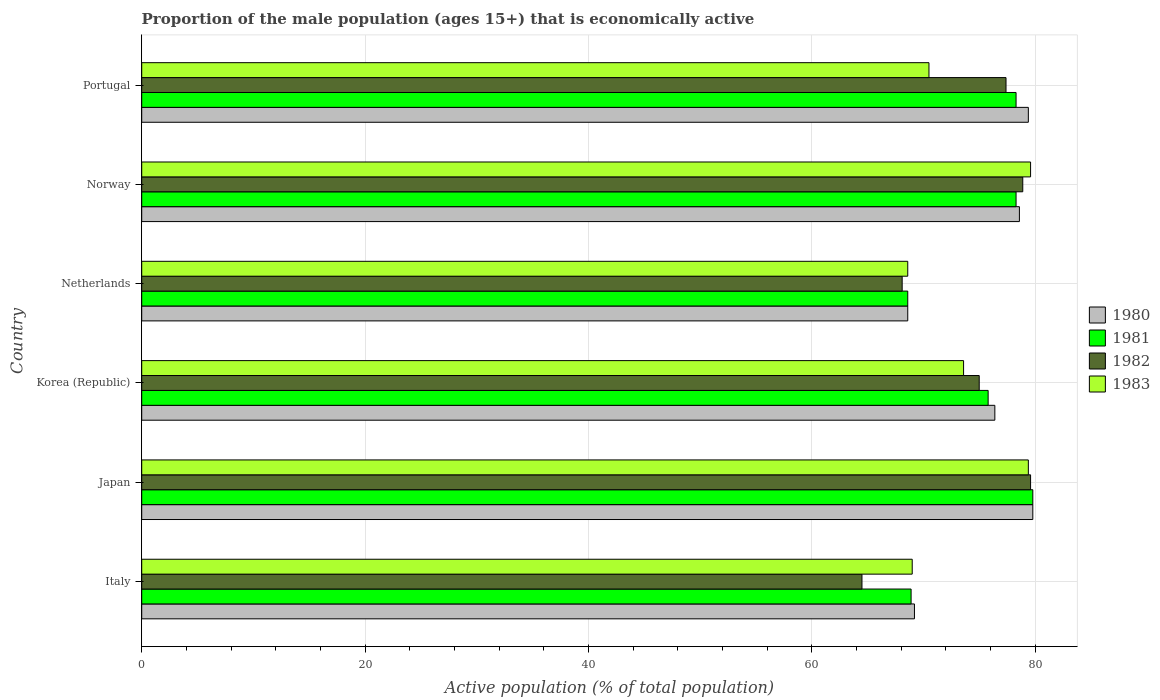How many different coloured bars are there?
Keep it short and to the point. 4. Are the number of bars per tick equal to the number of legend labels?
Make the answer very short. Yes. Are the number of bars on each tick of the Y-axis equal?
Provide a succinct answer. Yes. How many bars are there on the 6th tick from the bottom?
Give a very brief answer. 4. What is the proportion of the male population that is economically active in 1983 in Portugal?
Provide a short and direct response. 70.5. Across all countries, what is the maximum proportion of the male population that is economically active in 1983?
Your answer should be very brief. 79.6. Across all countries, what is the minimum proportion of the male population that is economically active in 1983?
Your answer should be compact. 68.6. In which country was the proportion of the male population that is economically active in 1982 maximum?
Keep it short and to the point. Japan. What is the total proportion of the male population that is economically active in 1982 in the graph?
Provide a short and direct response. 443.5. What is the difference between the proportion of the male population that is economically active in 1981 in Portugal and the proportion of the male population that is economically active in 1983 in Norway?
Make the answer very short. -1.3. What is the average proportion of the male population that is economically active in 1980 per country?
Your response must be concise. 75.33. What is the difference between the proportion of the male population that is economically active in 1981 and proportion of the male population that is economically active in 1982 in Norway?
Ensure brevity in your answer.  -0.6. What is the ratio of the proportion of the male population that is economically active in 1981 in Japan to that in Portugal?
Your answer should be very brief. 1.02. What is the difference between the highest and the second highest proportion of the male population that is economically active in 1983?
Your answer should be compact. 0.2. What is the difference between the highest and the lowest proportion of the male population that is economically active in 1982?
Offer a very short reply. 15.1. Is the sum of the proportion of the male population that is economically active in 1981 in Korea (Republic) and Portugal greater than the maximum proportion of the male population that is economically active in 1980 across all countries?
Keep it short and to the point. Yes. What does the 2nd bar from the bottom in Korea (Republic) represents?
Keep it short and to the point. 1981. Is it the case that in every country, the sum of the proportion of the male population that is economically active in 1981 and proportion of the male population that is economically active in 1980 is greater than the proportion of the male population that is economically active in 1982?
Offer a very short reply. Yes. Are all the bars in the graph horizontal?
Your answer should be very brief. Yes. How many countries are there in the graph?
Provide a succinct answer. 6. What is the difference between two consecutive major ticks on the X-axis?
Make the answer very short. 20. Does the graph contain any zero values?
Keep it short and to the point. No. Does the graph contain grids?
Your response must be concise. Yes. How are the legend labels stacked?
Keep it short and to the point. Vertical. What is the title of the graph?
Offer a terse response. Proportion of the male population (ages 15+) that is economically active. Does "1987" appear as one of the legend labels in the graph?
Your response must be concise. No. What is the label or title of the X-axis?
Provide a short and direct response. Active population (% of total population). What is the label or title of the Y-axis?
Provide a succinct answer. Country. What is the Active population (% of total population) of 1980 in Italy?
Give a very brief answer. 69.2. What is the Active population (% of total population) in 1981 in Italy?
Provide a short and direct response. 68.9. What is the Active population (% of total population) in 1982 in Italy?
Provide a succinct answer. 64.5. What is the Active population (% of total population) of 1980 in Japan?
Keep it short and to the point. 79.8. What is the Active population (% of total population) of 1981 in Japan?
Offer a terse response. 79.8. What is the Active population (% of total population) in 1982 in Japan?
Your response must be concise. 79.6. What is the Active population (% of total population) in 1983 in Japan?
Your answer should be very brief. 79.4. What is the Active population (% of total population) of 1980 in Korea (Republic)?
Your response must be concise. 76.4. What is the Active population (% of total population) in 1981 in Korea (Republic)?
Ensure brevity in your answer.  75.8. What is the Active population (% of total population) of 1982 in Korea (Republic)?
Ensure brevity in your answer.  75. What is the Active population (% of total population) in 1983 in Korea (Republic)?
Offer a very short reply. 73.6. What is the Active population (% of total population) in 1980 in Netherlands?
Make the answer very short. 68.6. What is the Active population (% of total population) in 1981 in Netherlands?
Your answer should be very brief. 68.6. What is the Active population (% of total population) in 1982 in Netherlands?
Your response must be concise. 68.1. What is the Active population (% of total population) of 1983 in Netherlands?
Your response must be concise. 68.6. What is the Active population (% of total population) of 1980 in Norway?
Your answer should be compact. 78.6. What is the Active population (% of total population) in 1981 in Norway?
Provide a succinct answer. 78.3. What is the Active population (% of total population) in 1982 in Norway?
Offer a very short reply. 78.9. What is the Active population (% of total population) in 1983 in Norway?
Make the answer very short. 79.6. What is the Active population (% of total population) in 1980 in Portugal?
Your answer should be compact. 79.4. What is the Active population (% of total population) in 1981 in Portugal?
Offer a very short reply. 78.3. What is the Active population (% of total population) of 1982 in Portugal?
Your response must be concise. 77.4. What is the Active population (% of total population) of 1983 in Portugal?
Ensure brevity in your answer.  70.5. Across all countries, what is the maximum Active population (% of total population) of 1980?
Offer a terse response. 79.8. Across all countries, what is the maximum Active population (% of total population) in 1981?
Your response must be concise. 79.8. Across all countries, what is the maximum Active population (% of total population) of 1982?
Provide a succinct answer. 79.6. Across all countries, what is the maximum Active population (% of total population) in 1983?
Keep it short and to the point. 79.6. Across all countries, what is the minimum Active population (% of total population) of 1980?
Ensure brevity in your answer.  68.6. Across all countries, what is the minimum Active population (% of total population) in 1981?
Ensure brevity in your answer.  68.6. Across all countries, what is the minimum Active population (% of total population) of 1982?
Make the answer very short. 64.5. Across all countries, what is the minimum Active population (% of total population) of 1983?
Keep it short and to the point. 68.6. What is the total Active population (% of total population) of 1980 in the graph?
Make the answer very short. 452. What is the total Active population (% of total population) of 1981 in the graph?
Make the answer very short. 449.7. What is the total Active population (% of total population) of 1982 in the graph?
Ensure brevity in your answer.  443.5. What is the total Active population (% of total population) of 1983 in the graph?
Your answer should be very brief. 440.7. What is the difference between the Active population (% of total population) in 1980 in Italy and that in Japan?
Your response must be concise. -10.6. What is the difference between the Active population (% of total population) in 1982 in Italy and that in Japan?
Keep it short and to the point. -15.1. What is the difference between the Active population (% of total population) of 1980 in Italy and that in Netherlands?
Give a very brief answer. 0.6. What is the difference between the Active population (% of total population) of 1981 in Italy and that in Netherlands?
Ensure brevity in your answer.  0.3. What is the difference between the Active population (% of total population) of 1982 in Italy and that in Netherlands?
Your answer should be very brief. -3.6. What is the difference between the Active population (% of total population) in 1980 in Italy and that in Norway?
Your response must be concise. -9.4. What is the difference between the Active population (% of total population) in 1982 in Italy and that in Norway?
Your response must be concise. -14.4. What is the difference between the Active population (% of total population) in 1983 in Italy and that in Norway?
Provide a succinct answer. -10.6. What is the difference between the Active population (% of total population) in 1980 in Italy and that in Portugal?
Ensure brevity in your answer.  -10.2. What is the difference between the Active population (% of total population) in 1982 in Italy and that in Portugal?
Your response must be concise. -12.9. What is the difference between the Active population (% of total population) of 1981 in Japan and that in Korea (Republic)?
Provide a short and direct response. 4. What is the difference between the Active population (% of total population) of 1982 in Japan and that in Korea (Republic)?
Give a very brief answer. 4.6. What is the difference between the Active population (% of total population) of 1982 in Japan and that in Netherlands?
Ensure brevity in your answer.  11.5. What is the difference between the Active population (% of total population) of 1980 in Japan and that in Norway?
Make the answer very short. 1.2. What is the difference between the Active population (% of total population) of 1981 in Japan and that in Norway?
Your response must be concise. 1.5. What is the difference between the Active population (% of total population) of 1980 in Japan and that in Portugal?
Give a very brief answer. 0.4. What is the difference between the Active population (% of total population) in 1982 in Japan and that in Portugal?
Your response must be concise. 2.2. What is the difference between the Active population (% of total population) in 1981 in Korea (Republic) and that in Netherlands?
Your answer should be compact. 7.2. What is the difference between the Active population (% of total population) of 1982 in Korea (Republic) and that in Netherlands?
Provide a succinct answer. 6.9. What is the difference between the Active population (% of total population) in 1981 in Korea (Republic) and that in Norway?
Provide a short and direct response. -2.5. What is the difference between the Active population (% of total population) of 1982 in Korea (Republic) and that in Norway?
Ensure brevity in your answer.  -3.9. What is the difference between the Active population (% of total population) in 1983 in Korea (Republic) and that in Norway?
Keep it short and to the point. -6. What is the difference between the Active population (% of total population) in 1981 in Korea (Republic) and that in Portugal?
Provide a short and direct response. -2.5. What is the difference between the Active population (% of total population) of 1982 in Korea (Republic) and that in Portugal?
Offer a terse response. -2.4. What is the difference between the Active population (% of total population) of 1983 in Korea (Republic) and that in Portugal?
Ensure brevity in your answer.  3.1. What is the difference between the Active population (% of total population) of 1982 in Netherlands and that in Norway?
Make the answer very short. -10.8. What is the difference between the Active population (% of total population) in 1983 in Netherlands and that in Norway?
Ensure brevity in your answer.  -11. What is the difference between the Active population (% of total population) in 1982 in Netherlands and that in Portugal?
Give a very brief answer. -9.3. What is the difference between the Active population (% of total population) in 1981 in Norway and that in Portugal?
Your answer should be compact. 0. What is the difference between the Active population (% of total population) in 1980 in Italy and the Active population (% of total population) in 1982 in Japan?
Offer a terse response. -10.4. What is the difference between the Active population (% of total population) of 1980 in Italy and the Active population (% of total population) of 1983 in Japan?
Offer a very short reply. -10.2. What is the difference between the Active population (% of total population) in 1981 in Italy and the Active population (% of total population) in 1983 in Japan?
Your response must be concise. -10.5. What is the difference between the Active population (% of total population) in 1982 in Italy and the Active population (% of total population) in 1983 in Japan?
Give a very brief answer. -14.9. What is the difference between the Active population (% of total population) of 1981 in Italy and the Active population (% of total population) of 1982 in Korea (Republic)?
Offer a terse response. -6.1. What is the difference between the Active population (% of total population) of 1982 in Italy and the Active population (% of total population) of 1983 in Korea (Republic)?
Ensure brevity in your answer.  -9.1. What is the difference between the Active population (% of total population) in 1980 in Italy and the Active population (% of total population) in 1981 in Netherlands?
Offer a terse response. 0.6. What is the difference between the Active population (% of total population) of 1980 in Italy and the Active population (% of total population) of 1982 in Netherlands?
Provide a succinct answer. 1.1. What is the difference between the Active population (% of total population) of 1981 in Italy and the Active population (% of total population) of 1982 in Netherlands?
Keep it short and to the point. 0.8. What is the difference between the Active population (% of total population) of 1982 in Italy and the Active population (% of total population) of 1983 in Netherlands?
Keep it short and to the point. -4.1. What is the difference between the Active population (% of total population) in 1980 in Italy and the Active population (% of total population) in 1981 in Norway?
Provide a short and direct response. -9.1. What is the difference between the Active population (% of total population) of 1980 in Italy and the Active population (% of total population) of 1983 in Norway?
Make the answer very short. -10.4. What is the difference between the Active population (% of total population) of 1981 in Italy and the Active population (% of total population) of 1982 in Norway?
Your response must be concise. -10. What is the difference between the Active population (% of total population) in 1981 in Italy and the Active population (% of total population) in 1983 in Norway?
Offer a terse response. -10.7. What is the difference between the Active population (% of total population) of 1982 in Italy and the Active population (% of total population) of 1983 in Norway?
Give a very brief answer. -15.1. What is the difference between the Active population (% of total population) of 1980 in Italy and the Active population (% of total population) of 1982 in Portugal?
Keep it short and to the point. -8.2. What is the difference between the Active population (% of total population) of 1980 in Japan and the Active population (% of total population) of 1981 in Korea (Republic)?
Ensure brevity in your answer.  4. What is the difference between the Active population (% of total population) in 1980 in Japan and the Active population (% of total population) in 1982 in Korea (Republic)?
Offer a very short reply. 4.8. What is the difference between the Active population (% of total population) of 1981 in Japan and the Active population (% of total population) of 1982 in Korea (Republic)?
Your answer should be very brief. 4.8. What is the difference between the Active population (% of total population) in 1982 in Japan and the Active population (% of total population) in 1983 in Korea (Republic)?
Your answer should be compact. 6. What is the difference between the Active population (% of total population) in 1980 in Japan and the Active population (% of total population) in 1981 in Netherlands?
Give a very brief answer. 11.2. What is the difference between the Active population (% of total population) in 1980 in Japan and the Active population (% of total population) in 1982 in Netherlands?
Make the answer very short. 11.7. What is the difference between the Active population (% of total population) of 1982 in Japan and the Active population (% of total population) of 1983 in Netherlands?
Ensure brevity in your answer.  11. What is the difference between the Active population (% of total population) of 1980 in Japan and the Active population (% of total population) of 1982 in Norway?
Your response must be concise. 0.9. What is the difference between the Active population (% of total population) of 1980 in Japan and the Active population (% of total population) of 1983 in Norway?
Provide a short and direct response. 0.2. What is the difference between the Active population (% of total population) in 1981 in Japan and the Active population (% of total population) in 1982 in Norway?
Offer a terse response. 0.9. What is the difference between the Active population (% of total population) of 1981 in Japan and the Active population (% of total population) of 1983 in Norway?
Provide a succinct answer. 0.2. What is the difference between the Active population (% of total population) of 1982 in Japan and the Active population (% of total population) of 1983 in Norway?
Make the answer very short. 0. What is the difference between the Active population (% of total population) in 1980 in Japan and the Active population (% of total population) in 1982 in Portugal?
Your response must be concise. 2.4. What is the difference between the Active population (% of total population) of 1981 in Japan and the Active population (% of total population) of 1983 in Portugal?
Offer a terse response. 9.3. What is the difference between the Active population (% of total population) in 1980 in Korea (Republic) and the Active population (% of total population) in 1983 in Netherlands?
Ensure brevity in your answer.  7.8. What is the difference between the Active population (% of total population) of 1981 in Korea (Republic) and the Active population (% of total population) of 1982 in Netherlands?
Your answer should be very brief. 7.7. What is the difference between the Active population (% of total population) in 1980 in Korea (Republic) and the Active population (% of total population) in 1981 in Norway?
Give a very brief answer. -1.9. What is the difference between the Active population (% of total population) in 1980 in Korea (Republic) and the Active population (% of total population) in 1983 in Norway?
Give a very brief answer. -3.2. What is the difference between the Active population (% of total population) in 1981 in Korea (Republic) and the Active population (% of total population) in 1983 in Norway?
Your answer should be very brief. -3.8. What is the difference between the Active population (% of total population) in 1980 in Korea (Republic) and the Active population (% of total population) in 1981 in Portugal?
Your answer should be compact. -1.9. What is the difference between the Active population (% of total population) of 1980 in Korea (Republic) and the Active population (% of total population) of 1982 in Portugal?
Offer a terse response. -1. What is the difference between the Active population (% of total population) of 1981 in Korea (Republic) and the Active population (% of total population) of 1983 in Portugal?
Give a very brief answer. 5.3. What is the difference between the Active population (% of total population) of 1982 in Korea (Republic) and the Active population (% of total population) of 1983 in Portugal?
Your answer should be compact. 4.5. What is the difference between the Active population (% of total population) of 1980 in Netherlands and the Active population (% of total population) of 1982 in Norway?
Your response must be concise. -10.3. What is the difference between the Active population (% of total population) of 1980 in Netherlands and the Active population (% of total population) of 1983 in Norway?
Provide a short and direct response. -11. What is the difference between the Active population (% of total population) in 1982 in Netherlands and the Active population (% of total population) in 1983 in Norway?
Your response must be concise. -11.5. What is the difference between the Active population (% of total population) in 1980 in Netherlands and the Active population (% of total population) in 1982 in Portugal?
Provide a short and direct response. -8.8. What is the difference between the Active population (% of total population) in 1981 in Netherlands and the Active population (% of total population) in 1983 in Portugal?
Make the answer very short. -1.9. What is the difference between the Active population (% of total population) in 1980 in Norway and the Active population (% of total population) in 1981 in Portugal?
Your answer should be very brief. 0.3. What is the difference between the Active population (% of total population) of 1980 in Norway and the Active population (% of total population) of 1982 in Portugal?
Keep it short and to the point. 1.2. What is the difference between the Active population (% of total population) of 1981 in Norway and the Active population (% of total population) of 1982 in Portugal?
Your response must be concise. 0.9. What is the average Active population (% of total population) of 1980 per country?
Provide a short and direct response. 75.33. What is the average Active population (% of total population) of 1981 per country?
Ensure brevity in your answer.  74.95. What is the average Active population (% of total population) of 1982 per country?
Give a very brief answer. 73.92. What is the average Active population (% of total population) in 1983 per country?
Offer a very short reply. 73.45. What is the difference between the Active population (% of total population) of 1981 and Active population (% of total population) of 1982 in Italy?
Your response must be concise. 4.4. What is the difference between the Active population (% of total population) of 1981 and Active population (% of total population) of 1983 in Italy?
Provide a succinct answer. -0.1. What is the difference between the Active population (% of total population) of 1980 and Active population (% of total population) of 1982 in Japan?
Make the answer very short. 0.2. What is the difference between the Active population (% of total population) in 1981 and Active population (% of total population) in 1983 in Japan?
Offer a very short reply. 0.4. What is the difference between the Active population (% of total population) of 1982 and Active population (% of total population) of 1983 in Japan?
Give a very brief answer. 0.2. What is the difference between the Active population (% of total population) of 1980 and Active population (% of total population) of 1981 in Korea (Republic)?
Your answer should be compact. 0.6. What is the difference between the Active population (% of total population) of 1980 and Active population (% of total population) of 1982 in Korea (Republic)?
Give a very brief answer. 1.4. What is the difference between the Active population (% of total population) in 1980 and Active population (% of total population) in 1981 in Netherlands?
Your answer should be compact. 0. What is the difference between the Active population (% of total population) in 1981 and Active population (% of total population) in 1982 in Netherlands?
Make the answer very short. 0.5. What is the difference between the Active population (% of total population) in 1982 and Active population (% of total population) in 1983 in Netherlands?
Offer a terse response. -0.5. What is the difference between the Active population (% of total population) of 1981 and Active population (% of total population) of 1982 in Norway?
Provide a short and direct response. -0.6. What is the difference between the Active population (% of total population) of 1982 and Active population (% of total population) of 1983 in Norway?
Your response must be concise. -0.7. What is the difference between the Active population (% of total population) in 1980 and Active population (% of total population) in 1982 in Portugal?
Provide a succinct answer. 2. What is the difference between the Active population (% of total population) of 1980 and Active population (% of total population) of 1983 in Portugal?
Offer a terse response. 8.9. What is the difference between the Active population (% of total population) of 1981 and Active population (% of total population) of 1982 in Portugal?
Your answer should be compact. 0.9. What is the ratio of the Active population (% of total population) in 1980 in Italy to that in Japan?
Your response must be concise. 0.87. What is the ratio of the Active population (% of total population) in 1981 in Italy to that in Japan?
Offer a terse response. 0.86. What is the ratio of the Active population (% of total population) in 1982 in Italy to that in Japan?
Your answer should be very brief. 0.81. What is the ratio of the Active population (% of total population) of 1983 in Italy to that in Japan?
Keep it short and to the point. 0.87. What is the ratio of the Active population (% of total population) in 1980 in Italy to that in Korea (Republic)?
Ensure brevity in your answer.  0.91. What is the ratio of the Active population (% of total population) in 1981 in Italy to that in Korea (Republic)?
Give a very brief answer. 0.91. What is the ratio of the Active population (% of total population) in 1982 in Italy to that in Korea (Republic)?
Ensure brevity in your answer.  0.86. What is the ratio of the Active population (% of total population) in 1983 in Italy to that in Korea (Republic)?
Provide a succinct answer. 0.94. What is the ratio of the Active population (% of total population) of 1980 in Italy to that in Netherlands?
Offer a terse response. 1.01. What is the ratio of the Active population (% of total population) in 1981 in Italy to that in Netherlands?
Provide a short and direct response. 1. What is the ratio of the Active population (% of total population) in 1982 in Italy to that in Netherlands?
Your answer should be compact. 0.95. What is the ratio of the Active population (% of total population) of 1980 in Italy to that in Norway?
Make the answer very short. 0.88. What is the ratio of the Active population (% of total population) in 1981 in Italy to that in Norway?
Give a very brief answer. 0.88. What is the ratio of the Active population (% of total population) in 1982 in Italy to that in Norway?
Make the answer very short. 0.82. What is the ratio of the Active population (% of total population) in 1983 in Italy to that in Norway?
Provide a short and direct response. 0.87. What is the ratio of the Active population (% of total population) in 1980 in Italy to that in Portugal?
Provide a short and direct response. 0.87. What is the ratio of the Active population (% of total population) in 1981 in Italy to that in Portugal?
Offer a terse response. 0.88. What is the ratio of the Active population (% of total population) in 1983 in Italy to that in Portugal?
Ensure brevity in your answer.  0.98. What is the ratio of the Active population (% of total population) in 1980 in Japan to that in Korea (Republic)?
Offer a terse response. 1.04. What is the ratio of the Active population (% of total population) in 1981 in Japan to that in Korea (Republic)?
Make the answer very short. 1.05. What is the ratio of the Active population (% of total population) in 1982 in Japan to that in Korea (Republic)?
Make the answer very short. 1.06. What is the ratio of the Active population (% of total population) in 1983 in Japan to that in Korea (Republic)?
Give a very brief answer. 1.08. What is the ratio of the Active population (% of total population) in 1980 in Japan to that in Netherlands?
Make the answer very short. 1.16. What is the ratio of the Active population (% of total population) in 1981 in Japan to that in Netherlands?
Keep it short and to the point. 1.16. What is the ratio of the Active population (% of total population) of 1982 in Japan to that in Netherlands?
Offer a terse response. 1.17. What is the ratio of the Active population (% of total population) in 1983 in Japan to that in Netherlands?
Offer a very short reply. 1.16. What is the ratio of the Active population (% of total population) in 1980 in Japan to that in Norway?
Offer a very short reply. 1.02. What is the ratio of the Active population (% of total population) in 1981 in Japan to that in Norway?
Offer a very short reply. 1.02. What is the ratio of the Active population (% of total population) in 1982 in Japan to that in Norway?
Give a very brief answer. 1.01. What is the ratio of the Active population (% of total population) of 1983 in Japan to that in Norway?
Give a very brief answer. 1. What is the ratio of the Active population (% of total population) in 1980 in Japan to that in Portugal?
Offer a terse response. 1. What is the ratio of the Active population (% of total population) of 1981 in Japan to that in Portugal?
Your response must be concise. 1.02. What is the ratio of the Active population (% of total population) of 1982 in Japan to that in Portugal?
Provide a short and direct response. 1.03. What is the ratio of the Active population (% of total population) in 1983 in Japan to that in Portugal?
Give a very brief answer. 1.13. What is the ratio of the Active population (% of total population) in 1980 in Korea (Republic) to that in Netherlands?
Keep it short and to the point. 1.11. What is the ratio of the Active population (% of total population) of 1981 in Korea (Republic) to that in Netherlands?
Ensure brevity in your answer.  1.1. What is the ratio of the Active population (% of total population) in 1982 in Korea (Republic) to that in Netherlands?
Your response must be concise. 1.1. What is the ratio of the Active population (% of total population) of 1983 in Korea (Republic) to that in Netherlands?
Give a very brief answer. 1.07. What is the ratio of the Active population (% of total population) of 1980 in Korea (Republic) to that in Norway?
Give a very brief answer. 0.97. What is the ratio of the Active population (% of total population) of 1981 in Korea (Republic) to that in Norway?
Make the answer very short. 0.97. What is the ratio of the Active population (% of total population) in 1982 in Korea (Republic) to that in Norway?
Your answer should be compact. 0.95. What is the ratio of the Active population (% of total population) of 1983 in Korea (Republic) to that in Norway?
Your answer should be very brief. 0.92. What is the ratio of the Active population (% of total population) in 1980 in Korea (Republic) to that in Portugal?
Provide a succinct answer. 0.96. What is the ratio of the Active population (% of total population) of 1981 in Korea (Republic) to that in Portugal?
Your response must be concise. 0.97. What is the ratio of the Active population (% of total population) in 1983 in Korea (Republic) to that in Portugal?
Your answer should be compact. 1.04. What is the ratio of the Active population (% of total population) of 1980 in Netherlands to that in Norway?
Ensure brevity in your answer.  0.87. What is the ratio of the Active population (% of total population) in 1981 in Netherlands to that in Norway?
Your answer should be very brief. 0.88. What is the ratio of the Active population (% of total population) of 1982 in Netherlands to that in Norway?
Your answer should be very brief. 0.86. What is the ratio of the Active population (% of total population) of 1983 in Netherlands to that in Norway?
Your answer should be compact. 0.86. What is the ratio of the Active population (% of total population) of 1980 in Netherlands to that in Portugal?
Offer a terse response. 0.86. What is the ratio of the Active population (% of total population) in 1981 in Netherlands to that in Portugal?
Give a very brief answer. 0.88. What is the ratio of the Active population (% of total population) in 1982 in Netherlands to that in Portugal?
Your answer should be compact. 0.88. What is the ratio of the Active population (% of total population) in 1982 in Norway to that in Portugal?
Provide a succinct answer. 1.02. What is the ratio of the Active population (% of total population) in 1983 in Norway to that in Portugal?
Make the answer very short. 1.13. What is the difference between the highest and the second highest Active population (% of total population) of 1980?
Offer a terse response. 0.4. What is the difference between the highest and the second highest Active population (% of total population) in 1981?
Keep it short and to the point. 1.5. What is the difference between the highest and the second highest Active population (% of total population) in 1982?
Offer a very short reply. 0.7. What is the difference between the highest and the second highest Active population (% of total population) of 1983?
Your response must be concise. 0.2. What is the difference between the highest and the lowest Active population (% of total population) in 1980?
Your answer should be compact. 11.2. 